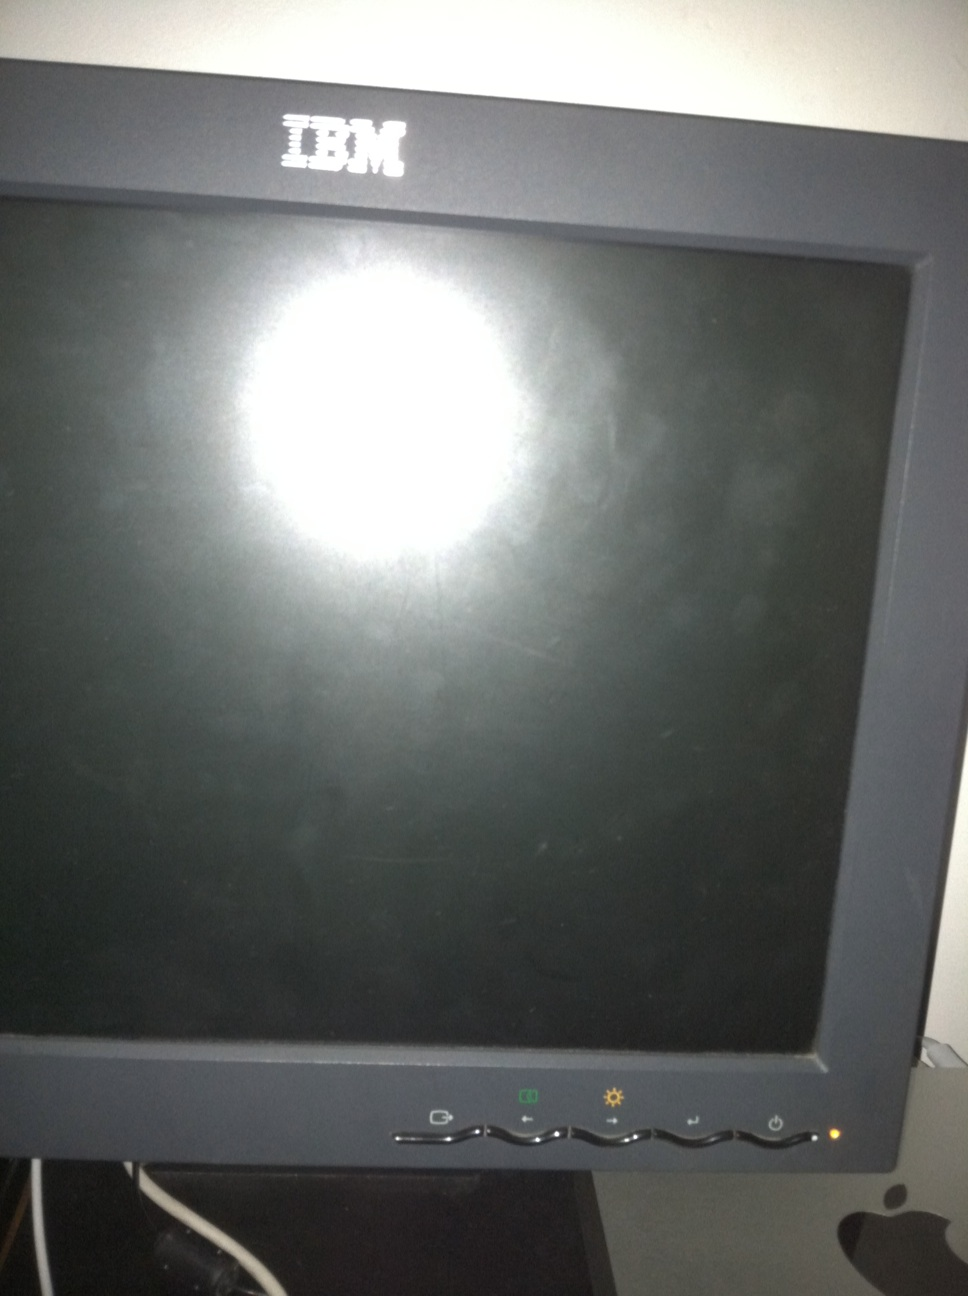What brand is this monitor, and how can that be identified? The monitor is an IBM brand, as evidenced by the logo located on the top center of the monitor's frame. What else can we infer about this monitor from its appearance? The monitor appears to be an older model due to its bulky CRT (Cathode Ray Tube) design, typical of earlier computer monitors before the widespread adoption of flat screens. 